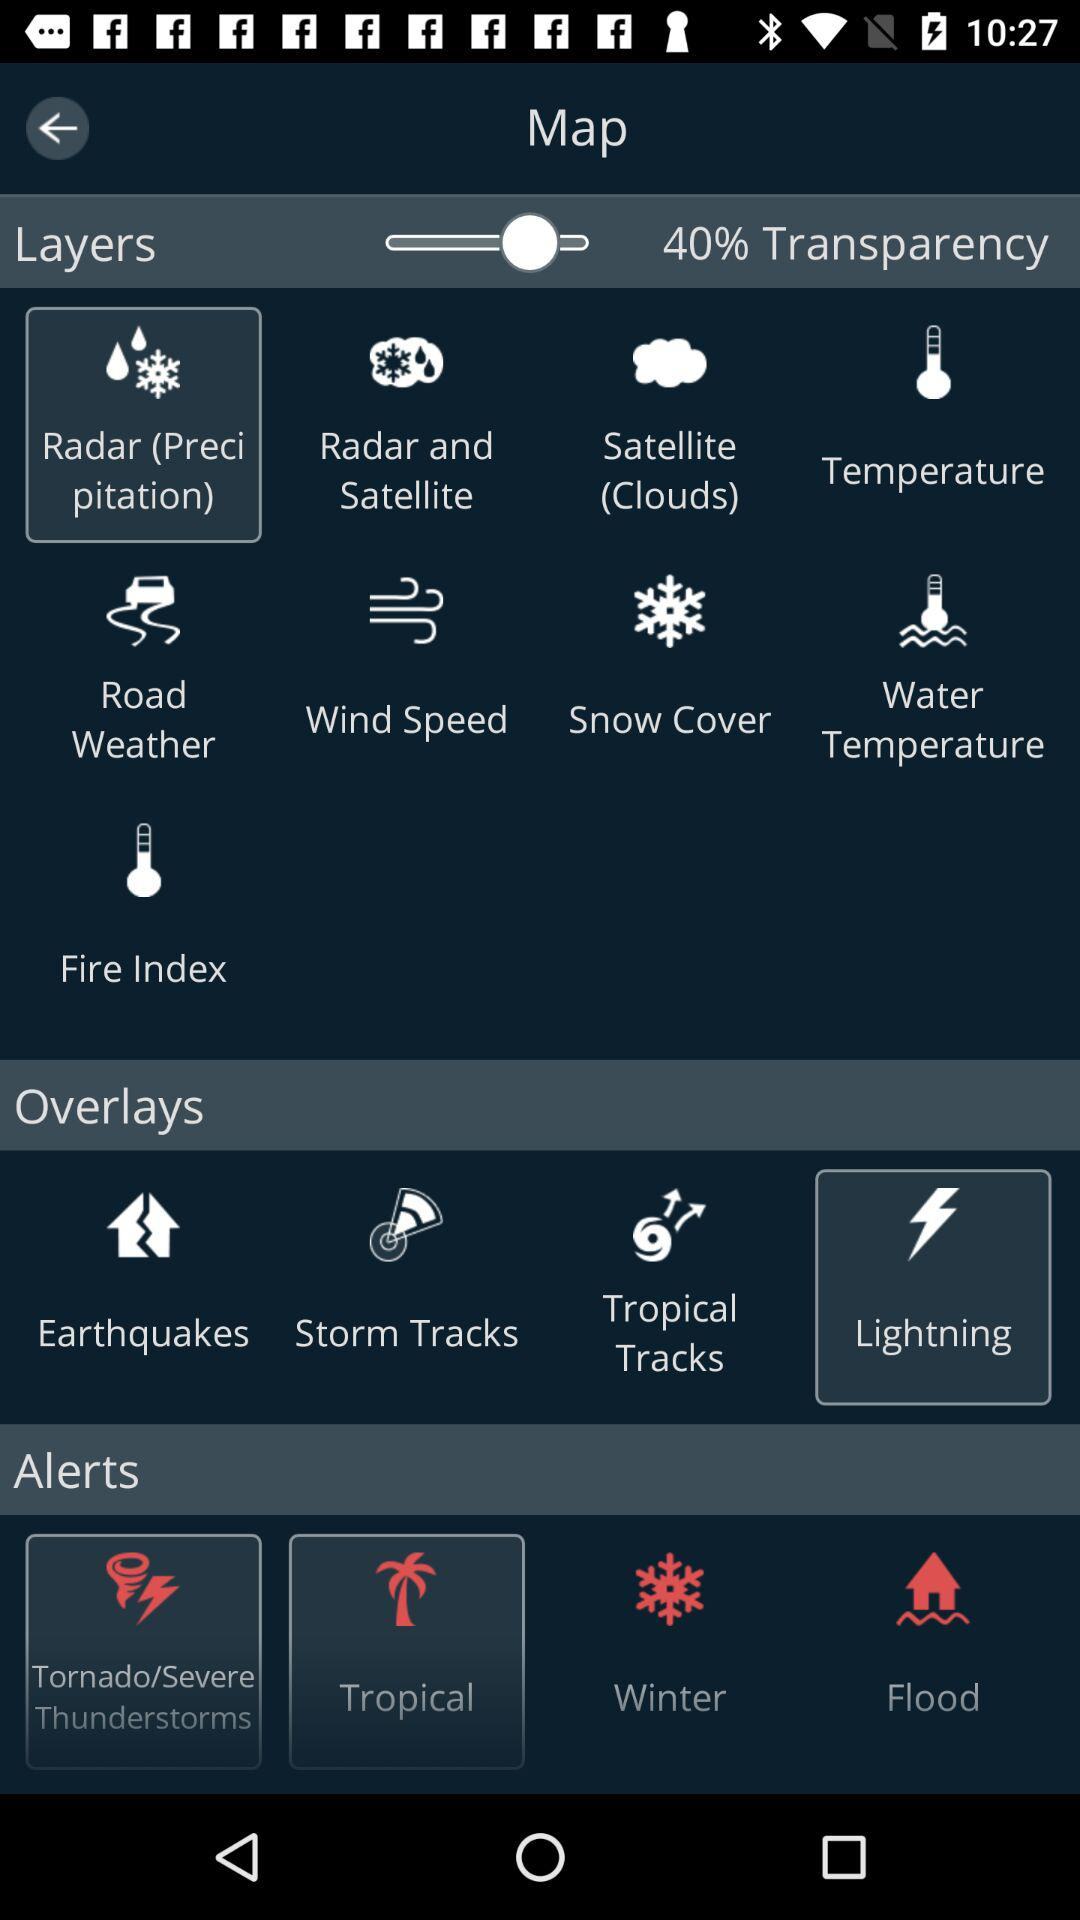What is the percentage of transparency? The percentage of transparency is 40%. 